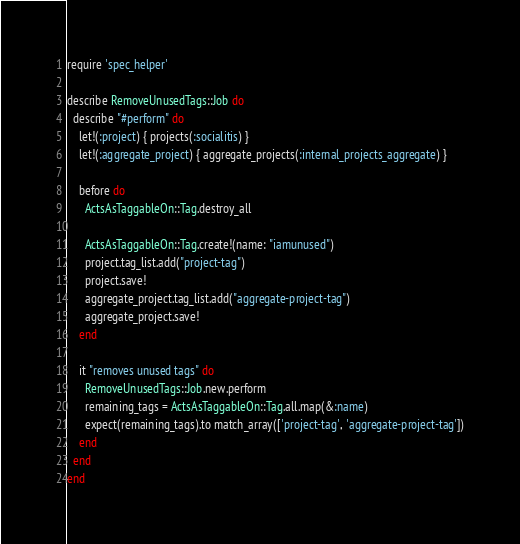Convert code to text. <code><loc_0><loc_0><loc_500><loc_500><_Ruby_>require 'spec_helper'

describe RemoveUnusedTags::Job do
  describe "#perform" do
    let!(:project) { projects(:socialitis) }
    let!(:aggregate_project) { aggregate_projects(:internal_projects_aggregate) }

    before do
      ActsAsTaggableOn::Tag.destroy_all

      ActsAsTaggableOn::Tag.create!(name: "iamunused")
      project.tag_list.add("project-tag")
      project.save!
      aggregate_project.tag_list.add("aggregate-project-tag")
      aggregate_project.save!
    end

    it "removes unused tags" do
      RemoveUnusedTags::Job.new.perform
      remaining_tags = ActsAsTaggableOn::Tag.all.map(&:name)
      expect(remaining_tags).to match_array(['project-tag', 'aggregate-project-tag'])
    end
  end
end
</code> 